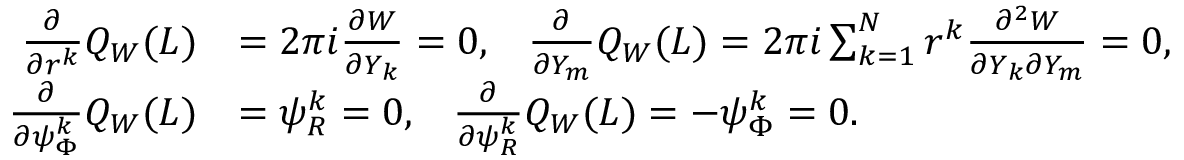Convert formula to latex. <formula><loc_0><loc_0><loc_500><loc_500>\begin{array} { r l } { \frac { \partial } { \partial r ^ { k } } Q _ { W } ( L ) } & { = 2 \pi i \frac { \partial W } { \partial Y _ { k } } = 0 , \, \frac { \partial } { \partial Y _ { m } } Q _ { W } ( L ) = 2 \pi i \sum _ { k = 1 } ^ { N } r ^ { k } \frac { \partial ^ { 2 } W } { \partial Y _ { k } \partial Y _ { m } } = 0 , } \\ { \frac { \partial } { \partial \psi _ { \Phi } ^ { k } } Q _ { W } ( L ) } & { = \psi _ { R } ^ { k } = 0 , \, \frac { \partial } { \partial \psi _ { R } ^ { k } } Q _ { W } ( L ) = - \psi _ { \Phi } ^ { k } = 0 . } \end{array}</formula> 